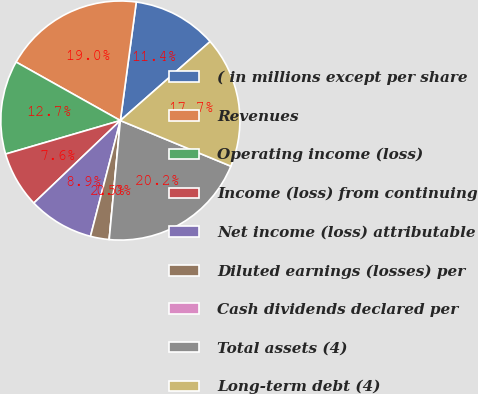<chart> <loc_0><loc_0><loc_500><loc_500><pie_chart><fcel>( in millions except per share<fcel>Revenues<fcel>Operating income (loss)<fcel>Income (loss) from continuing<fcel>Net income (loss) attributable<fcel>Diluted earnings (losses) per<fcel>Cash dividends declared per<fcel>Total assets (4)<fcel>Long-term debt (4)<nl><fcel>11.39%<fcel>18.99%<fcel>12.66%<fcel>7.6%<fcel>8.86%<fcel>2.53%<fcel>0.0%<fcel>20.25%<fcel>17.72%<nl></chart> 